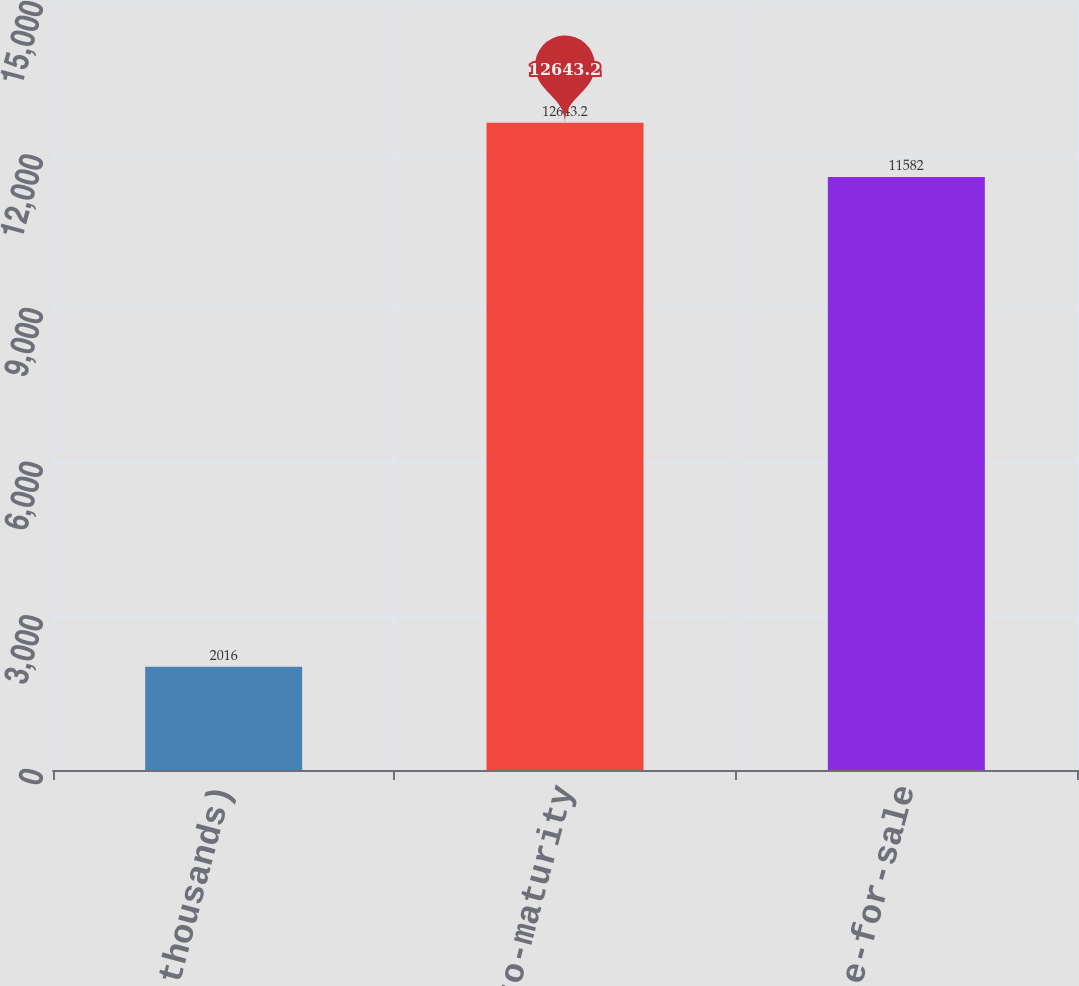<chart> <loc_0><loc_0><loc_500><loc_500><bar_chart><fcel>(In thousands)<fcel>Held-to-maturity<fcel>Available-for-sale<nl><fcel>2016<fcel>12643.2<fcel>11582<nl></chart> 